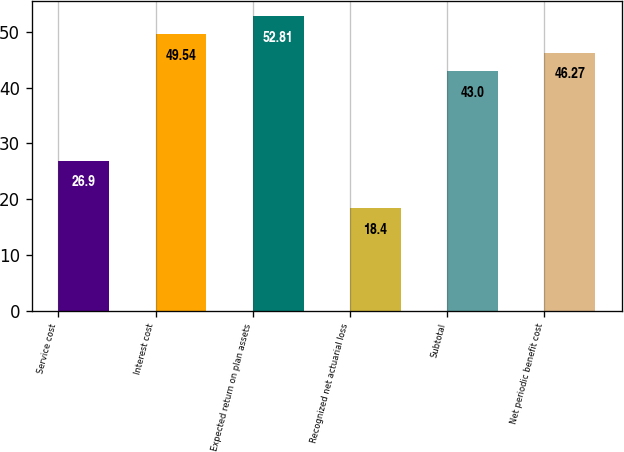<chart> <loc_0><loc_0><loc_500><loc_500><bar_chart><fcel>Service cost<fcel>Interest cost<fcel>Expected return on plan assets<fcel>Recognized net actuarial loss<fcel>Subtotal<fcel>Net periodic benefit cost<nl><fcel>26.9<fcel>49.54<fcel>52.81<fcel>18.4<fcel>43<fcel>46.27<nl></chart> 